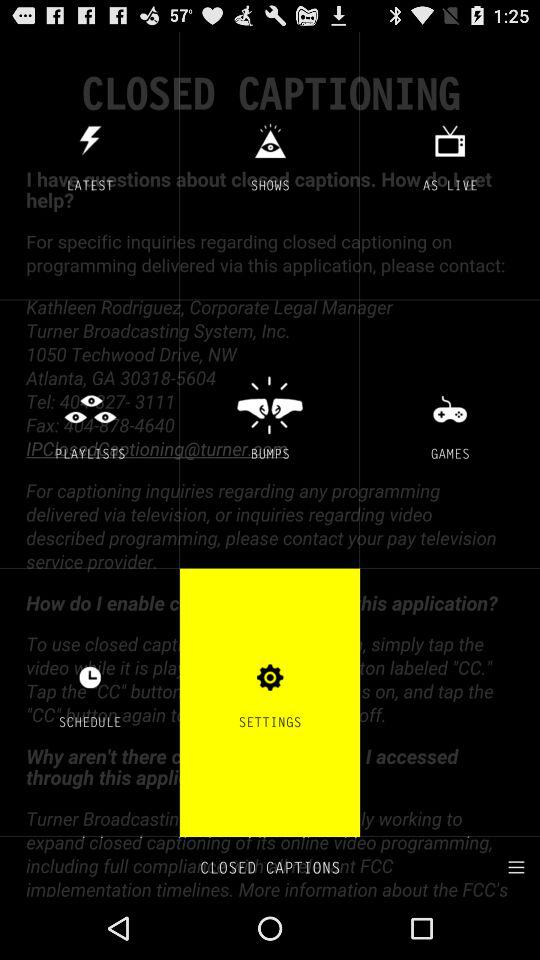How many notifications are there in "SETTINGS"?
When the provided information is insufficient, respond with <no answer>. <no answer> 